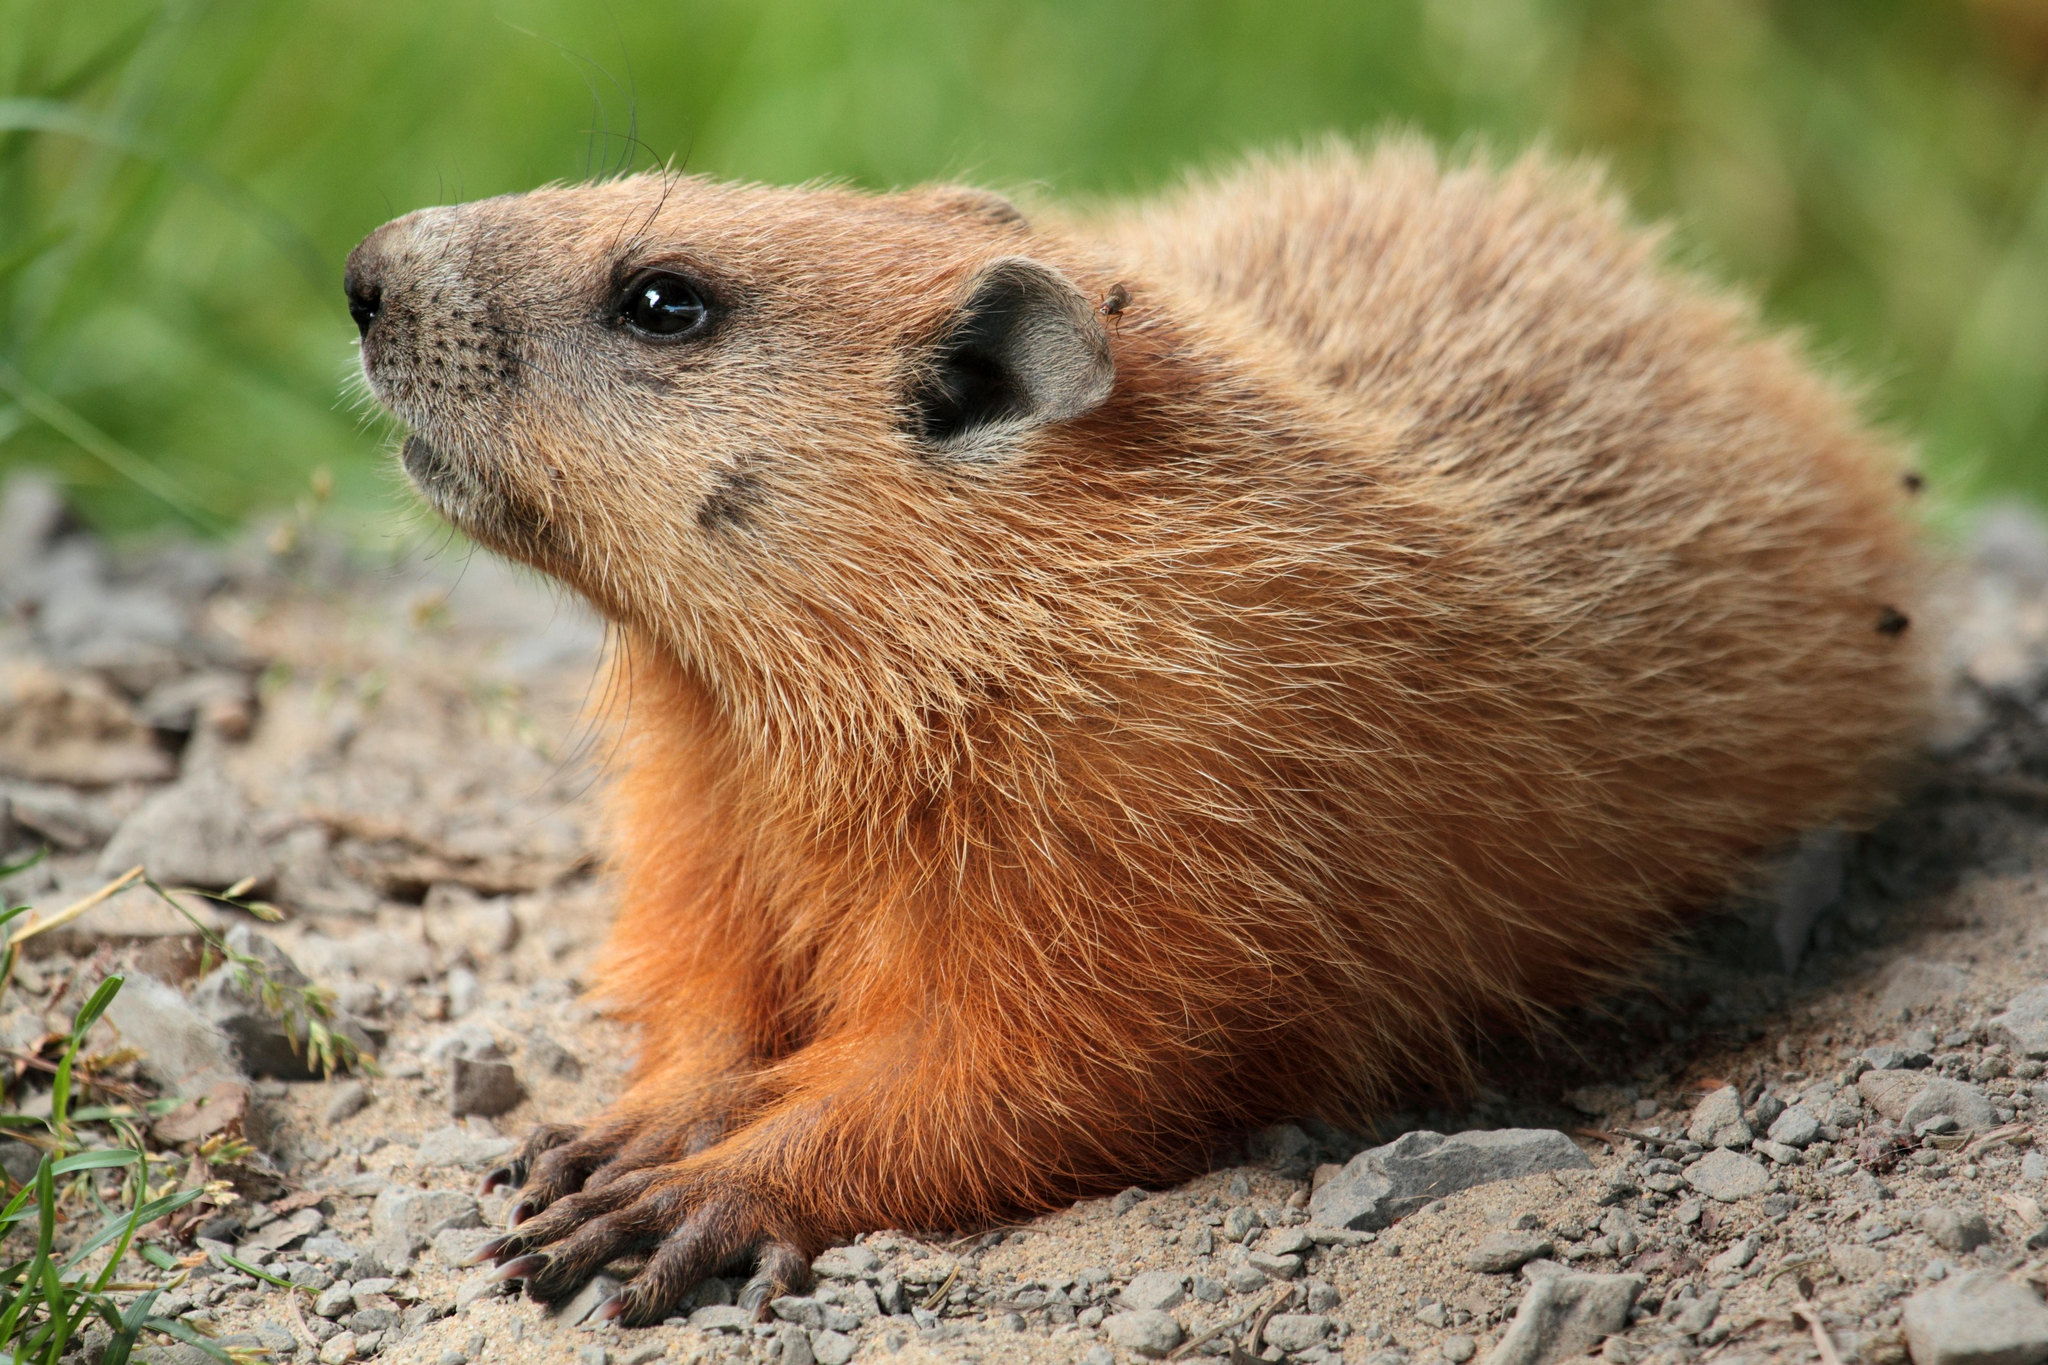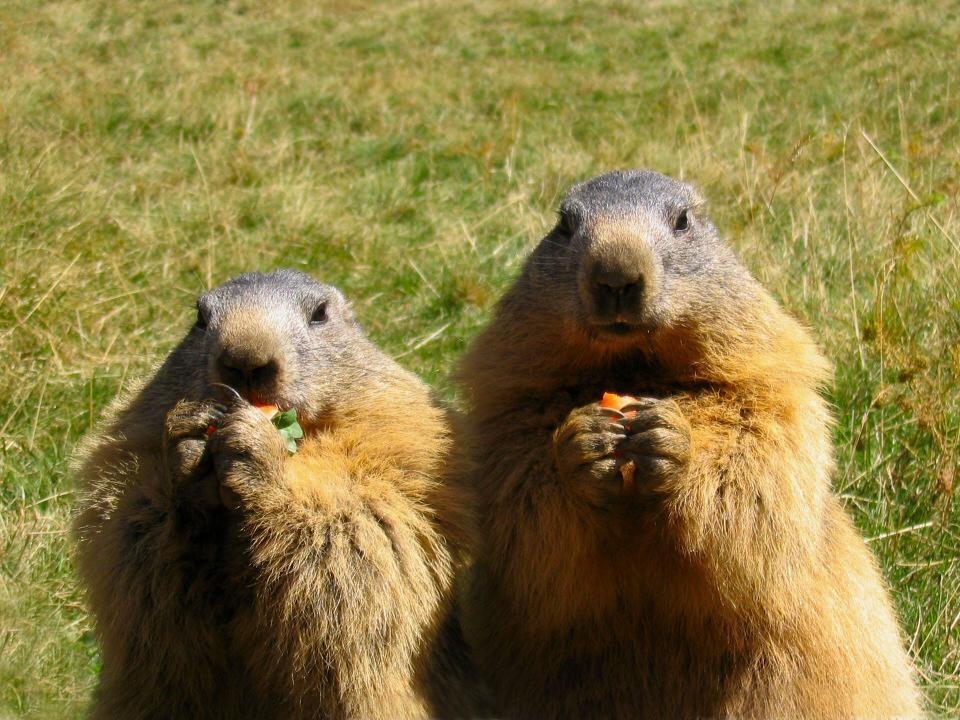The first image is the image on the left, the second image is the image on the right. For the images displayed, is the sentence "Two pairs of ground hogs are kissing." factually correct? Answer yes or no. No. The first image is the image on the left, the second image is the image on the right. For the images shown, is this caption "The marmots are touching in each image." true? Answer yes or no. No. 